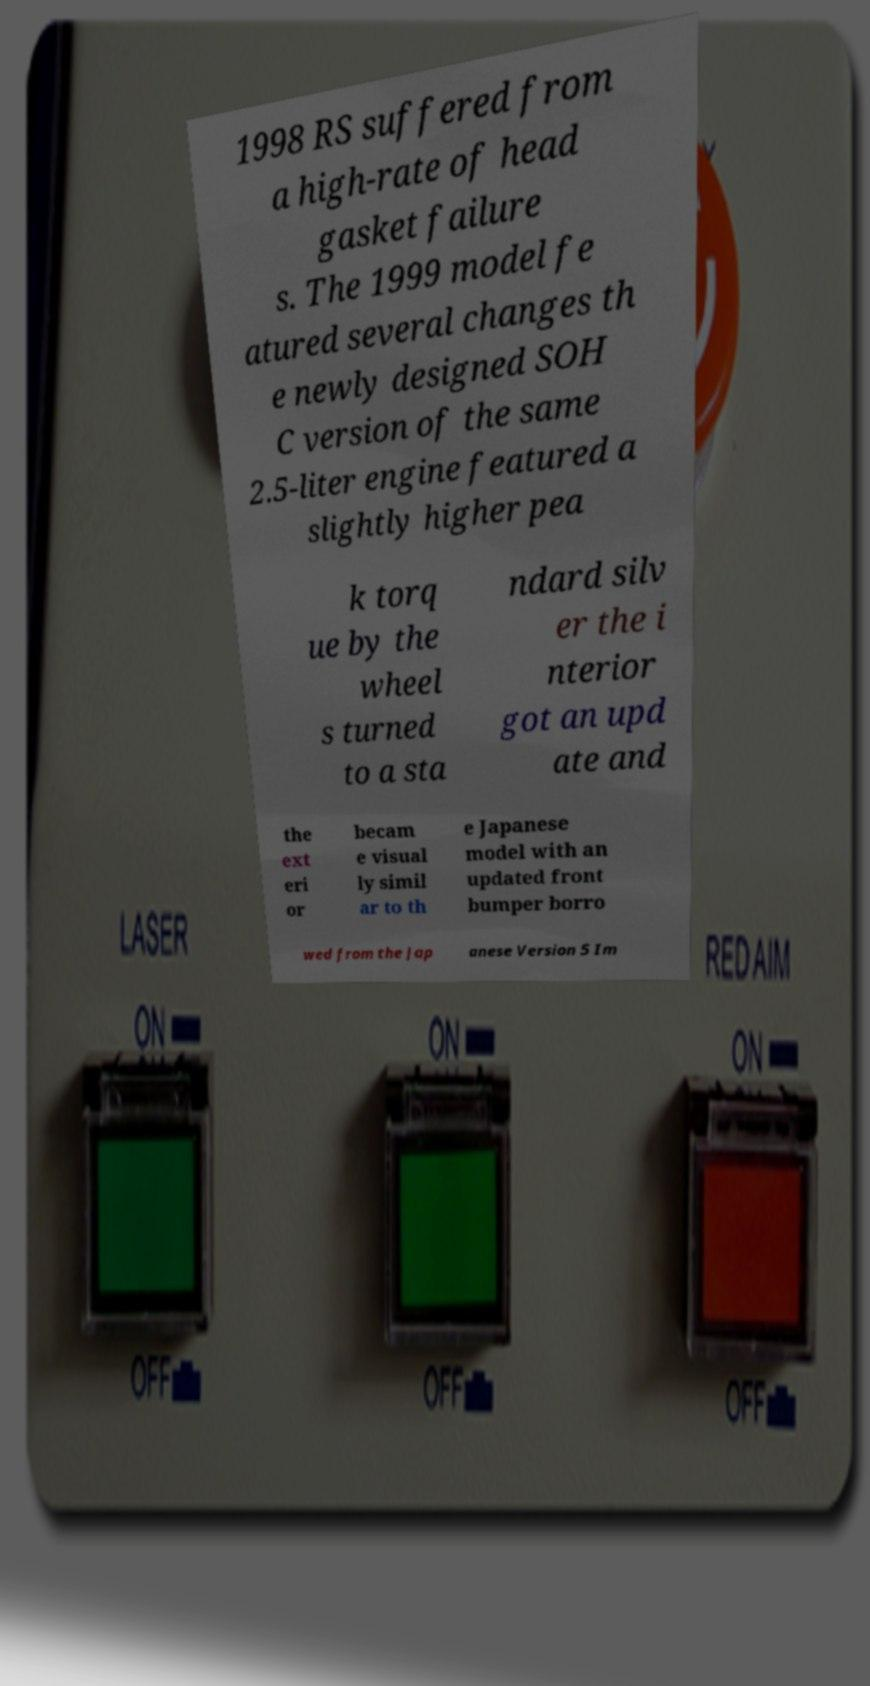I need the written content from this picture converted into text. Can you do that? 1998 RS suffered from a high-rate of head gasket failure s. The 1999 model fe atured several changes th e newly designed SOH C version of the same 2.5-liter engine featured a slightly higher pea k torq ue by the wheel s turned to a sta ndard silv er the i nterior got an upd ate and the ext eri or becam e visual ly simil ar to th e Japanese model with an updated front bumper borro wed from the Jap anese Version 5 Im 